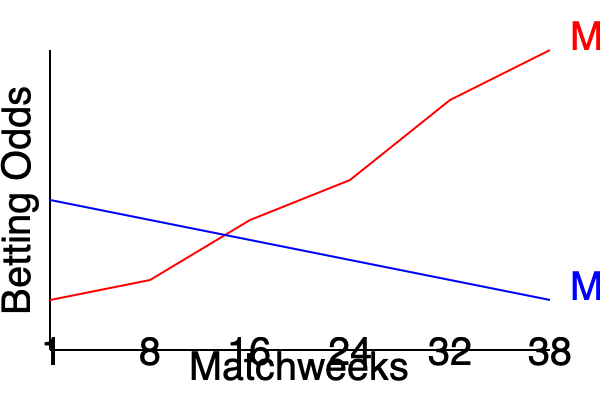Based on the line chart showing Premier League betting odds fluctuations over a season, what can be inferred about Manchester United's performance and betting prospects compared to Manchester City's as the season progressed? To interpret the line chart and answer the question, let's analyze the trends step-by-step:

1. Identify the teams:
   - Red line represents Manchester United
   - Blue line represents Manchester City

2. Interpret the y-axis:
   - Lower values indicate better odds (higher probability of winning)
   - Higher values indicate worse odds (lower probability of winning)

3. Analyze Manchester United's trend (red line):
   - Starts around the middle of the odds range
   - Consistently improves (moves downward) throughout the season
   - Ends with the best odds by the final matchweek

4. Analyze Manchester City's trend (blue line):
   - Starts with relatively good odds (lower on the chart)
   - Gradually worsens (moves upward) throughout the season
   - Ends with worse odds compared to their starting position

5. Compare the two teams:
   - Manchester United's odds improve significantly
   - Manchester City's odds worsen over time
   - The teams' positions switch, with United ending more favored than City

6. Infer performance:
   - Manchester United's improving odds suggest better performance as the season progressed
   - Manchester City's worsening odds imply declining performance or increased competition

7. Consider betting prospects:
   - Early in the season, betting on Manchester City might have been favored
   - As the season progressed, Manchester United became the more attractive betting option
   - The final weeks show United as the clear favorite between the two

Based on this analysis, we can infer that Manchester United's performance improved significantly throughout the season, making them an increasingly attractive betting prospect. In contrast, Manchester City's betting odds worsened, suggesting a decline in their perceived chances of success.
Answer: Manchester United's performance and betting prospects improved significantly, overtaking Manchester City by season's end. 